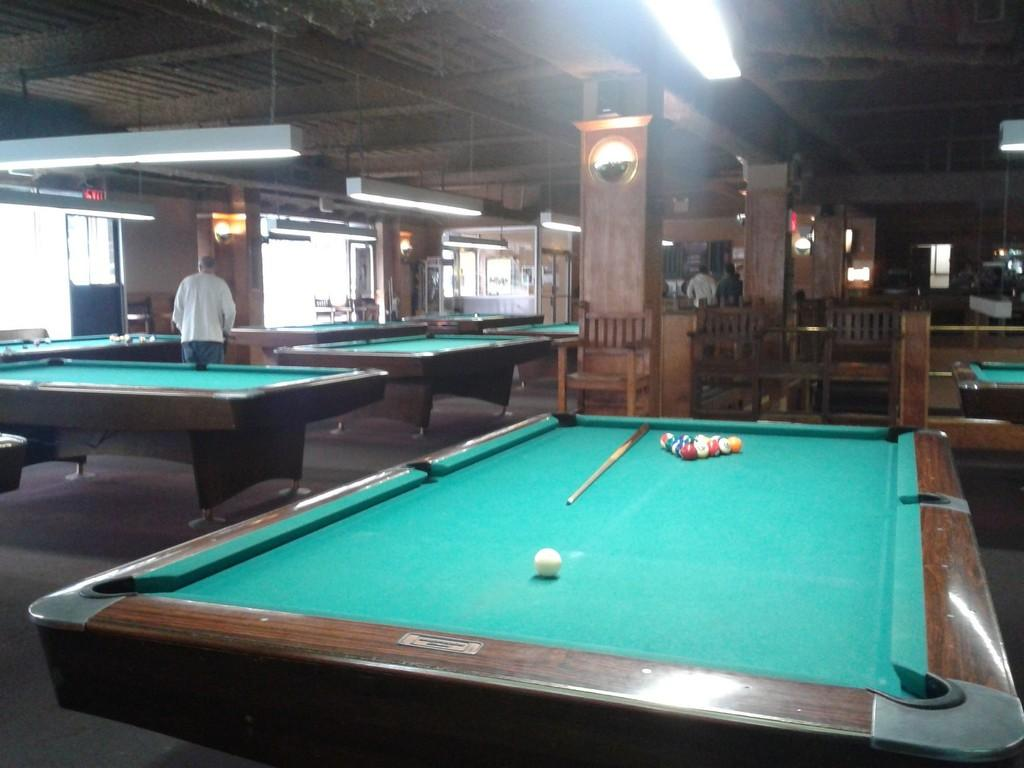Who is present in the room? There is a man in the room. What activity can be observed in the room? There are snooker tables in the room, which suggests that people might be playing snooker. What equipment is necessary for playing snooker? The snooker tables have sticks and balls on them, which are essential for playing the game. Where are the chairs placed in the room? The chairs are placed on the opposite side of the room. How do the giants interact with the snooker tables in the image? There are no giants present in the image; it only features a man and snooker tables. 